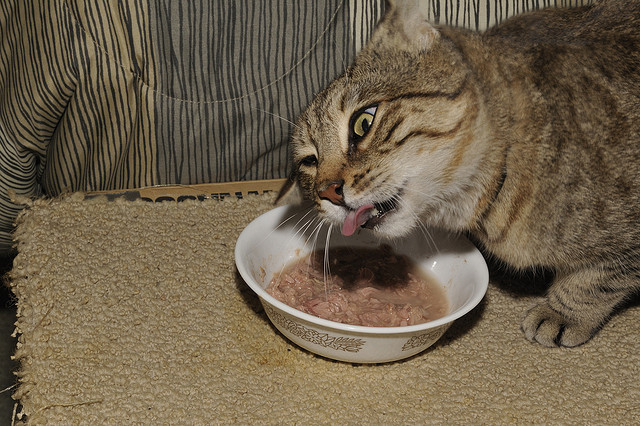What behavior of the cat might indicate its feelings or health status? The cat's active engagement with its food typically indicates good health and appetite. Alert eyes and a responsive attitude, as seen here, suggest well-being. However, monitoring for consistent eating patterns and any changes in behavior can be crucial to early detection of health issues. 